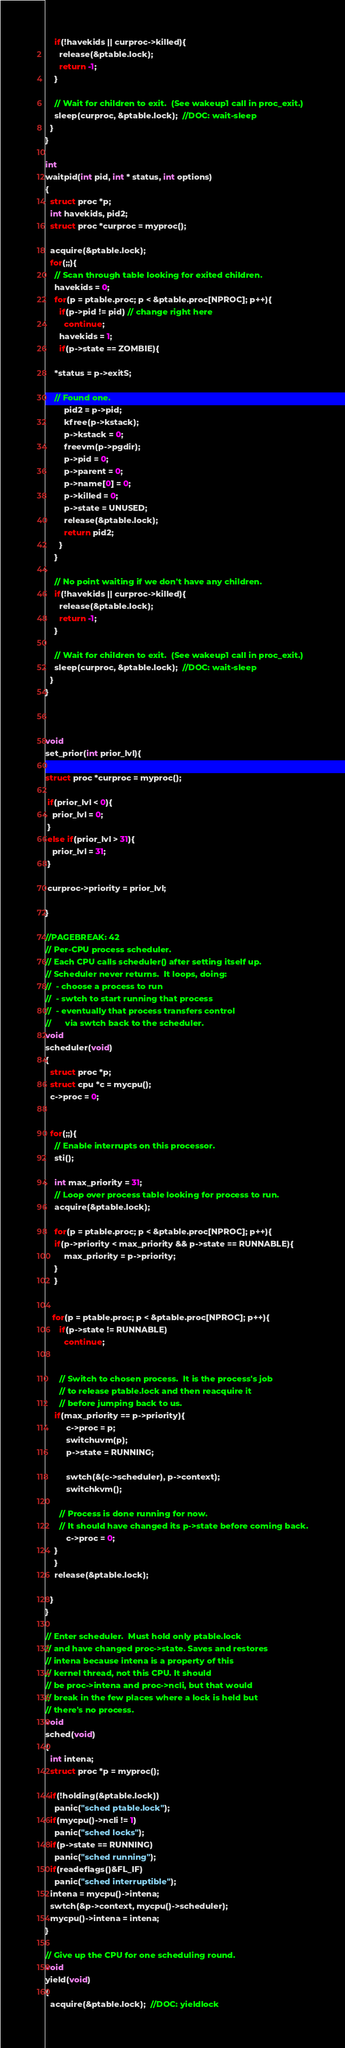<code> <loc_0><loc_0><loc_500><loc_500><_C_>    if(!havekids || curproc->killed){
      release(&ptable.lock);
      return -1;
    }

    // Wait for children to exit.  (See wakeup1 call in proc_exit.)
    sleep(curproc, &ptable.lock);  //DOC: wait-sleep
  }
}

int 
waitpid(int pid, int * status, int options)
{
  struct proc *p;
  int havekids, pid2;
  struct proc *curproc = myproc();
  
  acquire(&ptable.lock);
  for(;;){
    // Scan through table looking for exited children.
    havekids = 0;
    for(p = ptable.proc; p < &ptable.proc[NPROC]; p++){
      if(p->pid != pid) // change right here
        continue;
      havekids = 1;
      if(p->state == ZOMBIE){

	*status = p->exitS;        

	// Found one.
        pid2 = p->pid;
        kfree(p->kstack);
        p->kstack = 0;
        freevm(p->pgdir);
        p->pid = 0;
        p->parent = 0;
        p->name[0] = 0;
        p->killed = 0;
        p->state = UNUSED;
        release(&ptable.lock);
        return pid2;
      }
    }

    // No point waiting if we don't have any children.
    if(!havekids || curproc->killed){
      release(&ptable.lock);
      return -1;
    }

    // Wait for children to exit.  (See wakeup1 call in proc_exit.)
    sleep(curproc, &ptable.lock);  //DOC: wait-sleep
  }
}



void
set_prior(int prior_lvl){

struct proc *curproc = myproc();

 if(prior_lvl < 0){
   prior_lvl = 0;
 }
 else if(prior_lvl > 31){
   prior_lvl = 31;
 }

 curproc->priority = prior_lvl;

}

//PAGEBREAK: 42
// Per-CPU process scheduler.
// Each CPU calls scheduler() after setting itself up.
// Scheduler never returns.  It loops, doing:
//  - choose a process to run
//  - swtch to start running that process
//  - eventually that process transfers control
//      via swtch back to the scheduler.
void
scheduler(void)
{
  struct proc *p;
  struct cpu *c = mycpu();
  c->proc = 0;
 
 
  for(;;){
    // Enable interrupts on this processor.
    sti();

    int max_priority = 31;
    // Loop over process table looking for process to run.
    acquire(&ptable.lock);
 
    for(p = ptable.proc; p < &ptable.proc[NPROC]; p++){
  	if(p->priority < max_priority && p->state == RUNNABLE){
		max_priority = p->priority;
	}
    }


   for(p = ptable.proc; p < &ptable.proc[NPROC]; p++){
      if(p->state != RUNNABLE)
        continue;


      // Switch to chosen process.  It is the process's job
      // to release ptable.lock and then reacquire it
      // before jumping back to us.
	if(max_priority == p->priority){
     	 c->proc = p;
      	 switchuvm(p);
      	 p->state = RUNNING;

      	 swtch(&(c->scheduler), p->context);
     	 switchkvm();

      // Process is done running for now.
      // It should have changed its p->state before coming back.
     	 c->proc = 0;
	}
    }
    release(&ptable.lock);

  }
}

// Enter scheduler.  Must hold only ptable.lock
// and have changed proc->state. Saves and restores
// intena because intena is a property of this
// kernel thread, not this CPU. It should
// be proc->intena and proc->ncli, but that would
// break in the few places where a lock is held but
// there's no process.
void
sched(void)
{
  int intena;
  struct proc *p = myproc();

  if(!holding(&ptable.lock))
    panic("sched ptable.lock");
  if(mycpu()->ncli != 1)
    panic("sched locks");
  if(p->state == RUNNING)
    panic("sched running");
  if(readeflags()&FL_IF)
    panic("sched interruptible");
  intena = mycpu()->intena;
  swtch(&p->context, mycpu()->scheduler);
  mycpu()->intena = intena;
}

// Give up the CPU for one scheduling round.
void
yield(void)
{
  acquire(&ptable.lock);  //DOC: yieldlock</code> 